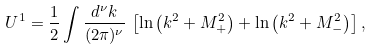Convert formula to latex. <formula><loc_0><loc_0><loc_500><loc_500>U ^ { 1 } = \frac { 1 } { 2 } \int \frac { d ^ { \nu } k } { ( 2 \pi ) ^ { \nu } } \, \left [ \ln \left ( k ^ { 2 } + M _ { + } ^ { 2 } \right ) + \ln \left ( k ^ { 2 } + M _ { - } ^ { 2 } \right ) \right ] ,</formula> 